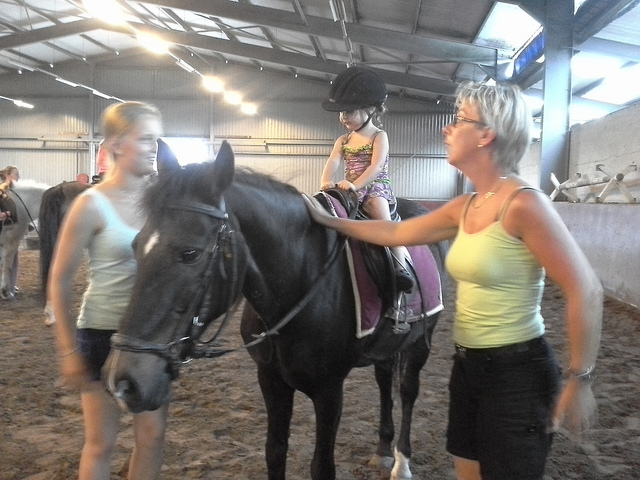<image>How old is the girl? I don't know how old the girl is. She can be 3, 4, or 24. How old is the girl? The age of the girl is unknown. 